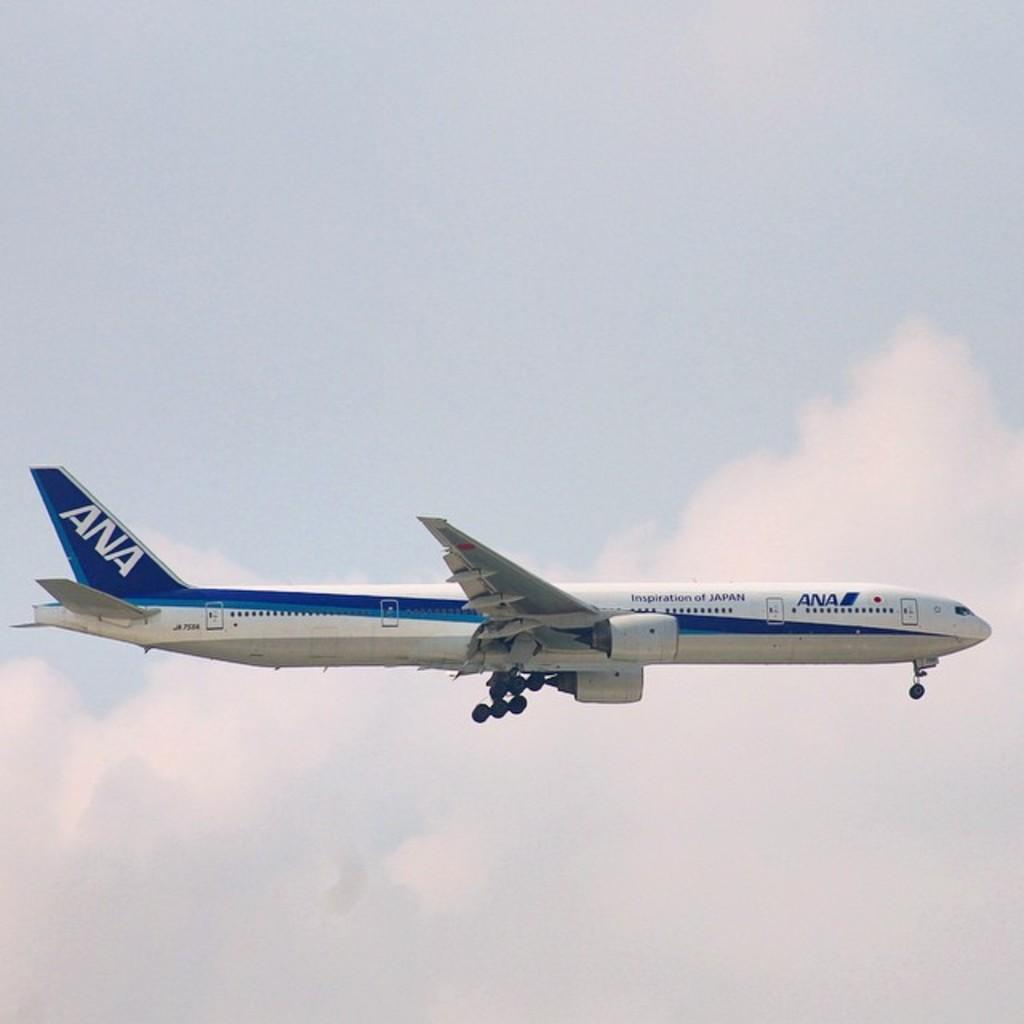<image>
Provide a brief description of the given image. A blue and white ANA jet liner flies through the sky with its landing gear showing. 